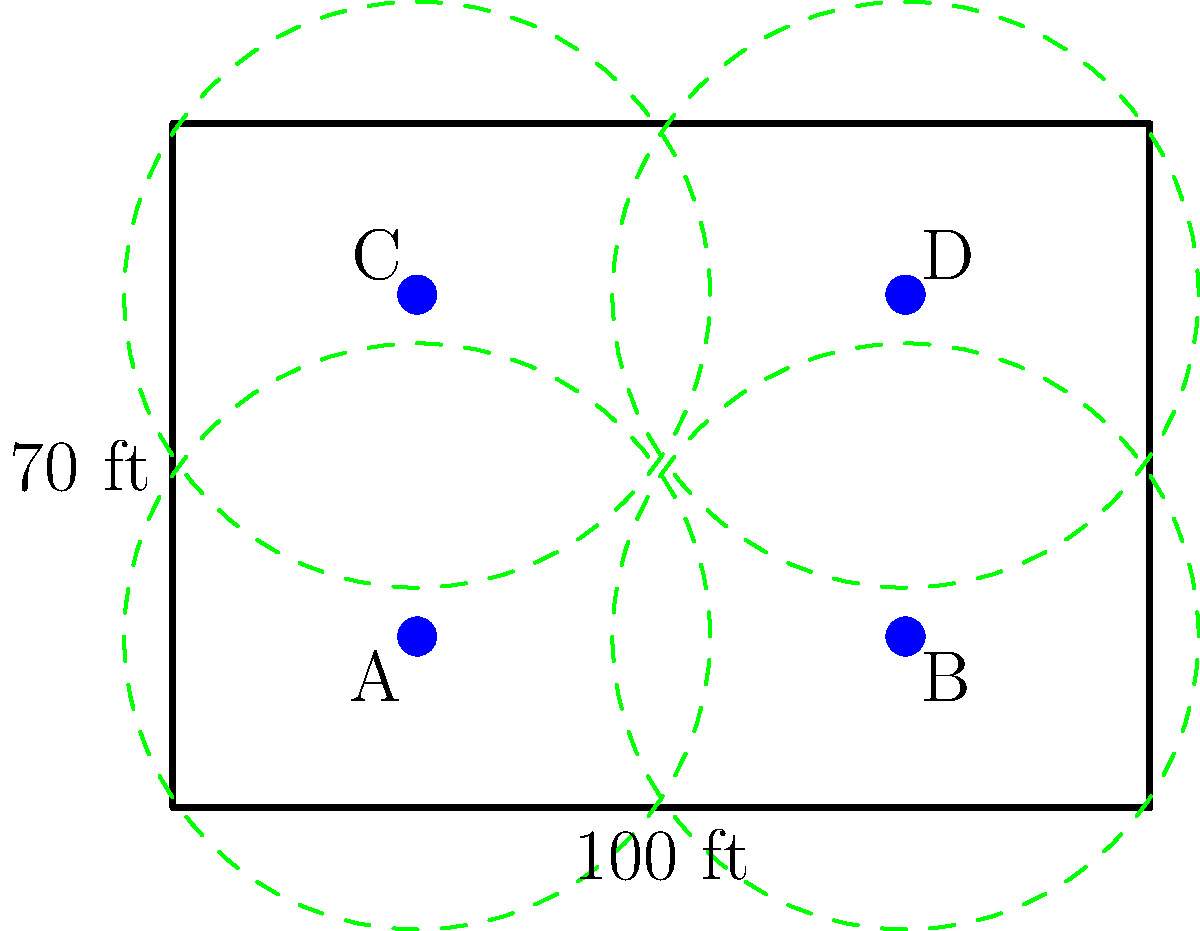In the baseball field sprinkler system layout shown above, which area of the field is likely to receive the least amount of water coverage? To determine the area with the least water coverage, we need to analyze the sprinkler layout and coverage patterns:

1. The field dimensions are 100 ft x 70 ft.
2. There are four sprinklers (A, B, C, and D) positioned symmetrically on the field.
3. Each sprinkler has a circular coverage area with a radius of approximately 30 ft.

4. Examining the coverage patterns:
   - The center of the field is well-covered, as it's within the range of all four sprinklers.
   - The sides of the field are covered by at least two sprinklers.
   - The corners of the field are only partially covered by one sprinkler each.

5. The areas with the least coverage are the corners of the field:
   - Top-left corner: partially covered by sprinkler C
   - Top-right corner: partially covered by sprinkler D
   - Bottom-left corner: partially covered by sprinkler A
   - Bottom-right corner: partially covered by sprinkler B

6. All four corners have similar coverage, but the exact corner points are outside the circular coverage areas.

Therefore, the areas receiving the least amount of water coverage are the corners of the field, particularly the exact corner points.
Answer: The corners of the field 